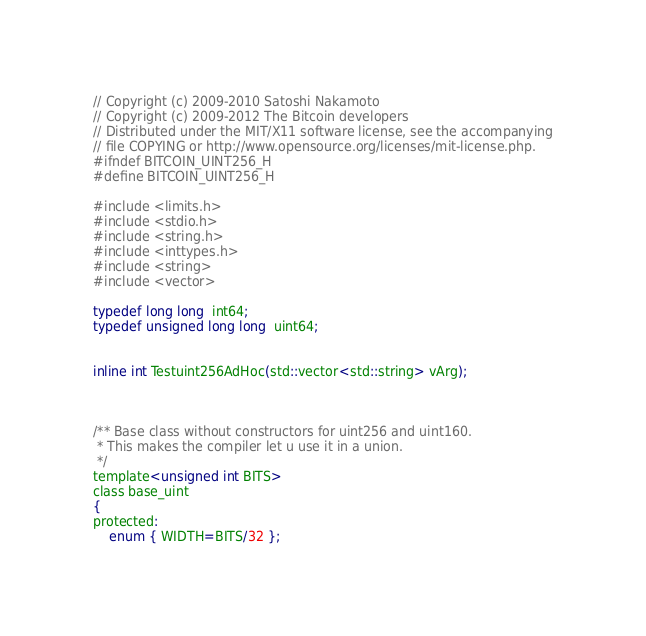Convert code to text. <code><loc_0><loc_0><loc_500><loc_500><_C_>// Copyright (c) 2009-2010 Satoshi Nakamoto
// Copyright (c) 2009-2012 The Bitcoin developers
// Distributed under the MIT/X11 software license, see the accompanying
// file COPYING or http://www.opensource.org/licenses/mit-license.php.
#ifndef BITCOIN_UINT256_H
#define BITCOIN_UINT256_H

#include <limits.h>
#include <stdio.h>
#include <string.h>
#include <inttypes.h>
#include <string>
#include <vector>

typedef long long  int64;
typedef unsigned long long  uint64;


inline int Testuint256AdHoc(std::vector<std::string> vArg);



/** Base class without constructors for uint256 and uint160.
 * This makes the compiler let u use it in a union.
 */
template<unsigned int BITS>
class base_uint
{
protected:
    enum { WIDTH=BITS/32 };</code> 